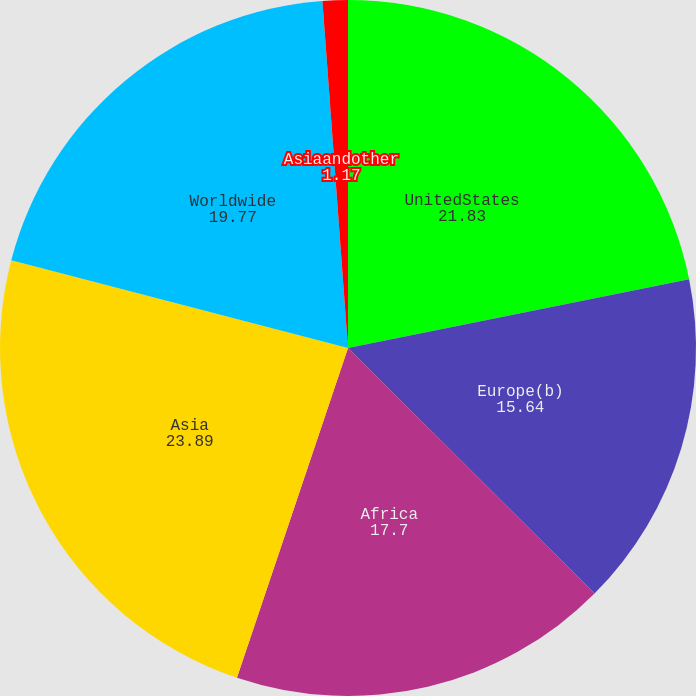<chart> <loc_0><loc_0><loc_500><loc_500><pie_chart><fcel>UnitedStates<fcel>Europe(b)<fcel>Africa<fcel>Asia<fcel>Worldwide<fcel>Asiaandother<nl><fcel>21.83%<fcel>15.64%<fcel>17.7%<fcel>23.89%<fcel>19.77%<fcel>1.17%<nl></chart> 